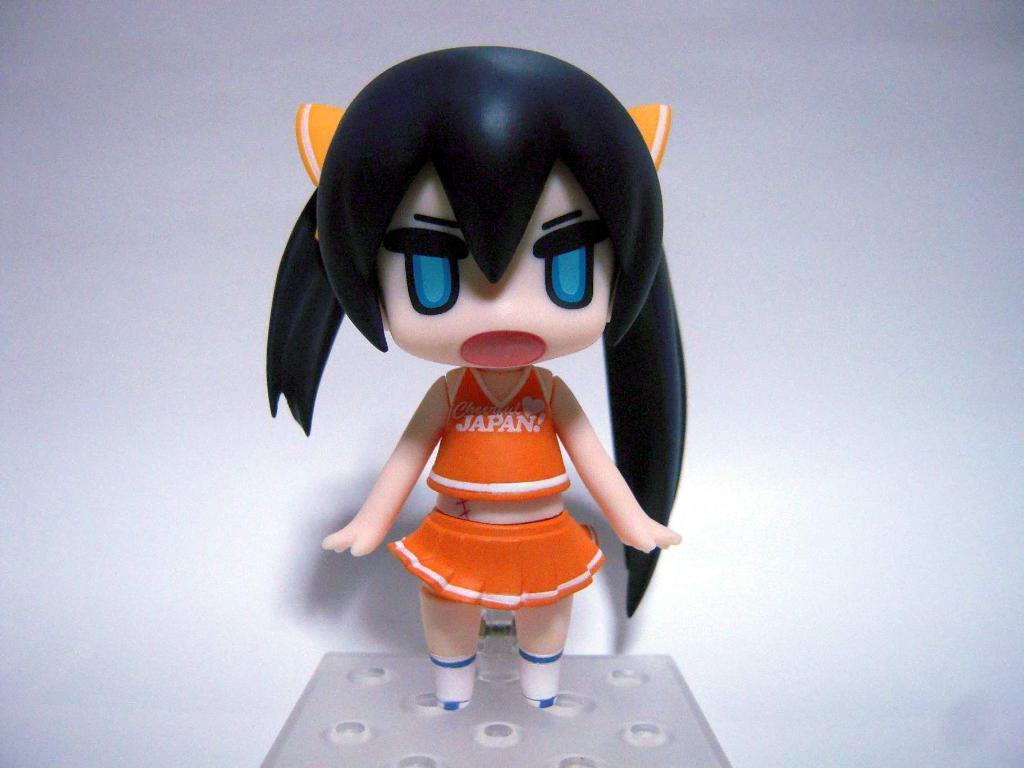What object can be seen in the image? There is a toy in the image. What color is the background of the image? The background of the image is white. What type of cork can be seen in the image? There is no cork present in the image. What kind of music is being played in the image? There is no music or indication of sound in the image. 